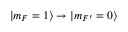Convert formula to latex. <formula><loc_0><loc_0><loc_500><loc_500>| m _ { F } = 1 \rangle \rightarrow | m _ { F ^ { \prime } } = 0 \rangle</formula> 